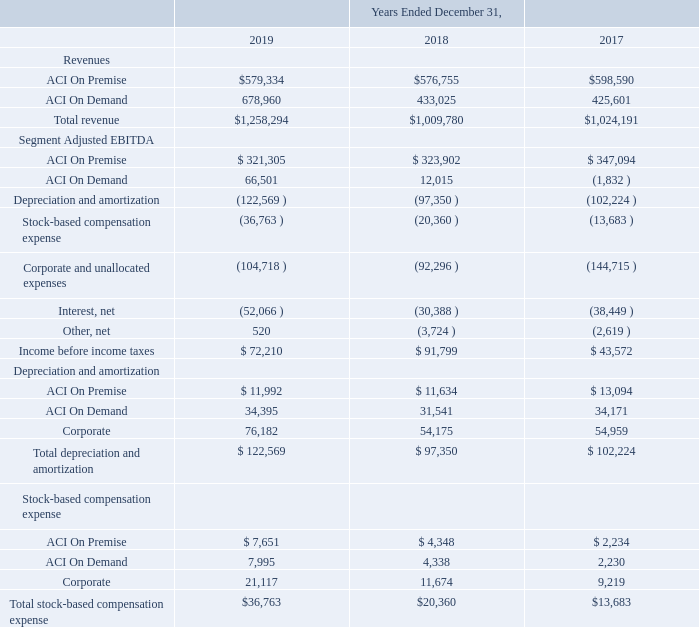10. Segment Information
The Company reports financial performance based on its segments, ACI On Premise and ACI On Demand, and analyzes Segment Adjusted EBITDA as a measure of segment profitability.
The Company’s interim Chief Executive Officer is also the chief operating decision maker ("CODM"). The CODM, together with other senior management personnel, focus their review on consolidated financial information and the allocation of resources based on operating results, including revenues and Segment Adjusted EBITDA, for each segment, separate from Corporate operations.
ACI On Premise serves customers who manage their software on site or through a third-party cloud service provider. These onpremise customers use the Company’s software to develop sophisticated solutions, which are often part of a larger system located and managed at the customer specified site. These customers require a level of control and flexibility that ACI On Premise solutions can offer, and they have the resources and expertise to take a lead role in managing these solutions.
ACI On Demand serves the needs of banks, merchants, and billers who use payments to facilitate their core business. These ondemand solutions are maintained and delivered through the cloud via our global data centers and are available in either a singletenant environment for SaaS offerings, or in a multi-tenant environment for PaaS offerings.
Revenue is attributed to the reportable segments based upon the product sold and mechanism for delivery to the customer. Expenses are attributed to the reportable segments in one of three methods, (1) direct costs of the segment, (2) labor costs that can be attributed based upon time tracking for individual products, or (3) costs that are allocated. Allocated costs are generally marketing and sales related activities as well as information technology and facilities related expense for which multiple segments benefit. The Company also allocates certain depreciation costs to the segments.
Segment Adjusted EBITDA is the measure reported to the CODM for purposes of making decisions on allocating resources and assessing the performance of the Company’s segments and, therefore, Segment Adjusted EBITDA is presented in conformity with ASC 280, Segment Reporting. Segment Adjusted EBITDA is defined as earnings (loss) from operations before interest, income tax expense (benefit), depreciation and amortization (“EBITDA”) adjusted to exclude stock-based compensation, and net other income (expense).
Corporate and unallocated expenses consist of the corporate overhead costs that are not allocated to reportable segments. These overhead costs relate to human resources, finance, legal, accounting, merger and acquisition activity, and other costs that are not considered when management evaluates segment performance. For the year ended December 31, 2017, corporate and unallocated expenses included $46.7 million of general and administrative expense for the legal judgment discussed in Note 15, Commitments and Contingencies.
The following is selected financial data for the Company’s reportable segments for the periods indicated (in thousands):
Assets are not allocated to segments, and the Company’s CODM does not evaluate operating segments using discrete asset information.
Which group of people does ACI on Premise serve? Customers who manage their software on site or through a third-party cloud service provider. Which group of people does ACI on Demand serve? The needs of banks, merchants, and billers who use payments to facilitate their core business. What was the ACI on Premise revenue in 2019?
Answer scale should be: thousand. $579,334. What was the change in ACI on demand revenue between 2018 and 2019?
Answer scale should be: thousand. 678,960-433,025
Answer: 245935. What was the change in total revenue between 2018 and 2017?
Answer scale should be: thousand. $1,009,780-$1,024,191
Answer: -14411. What was the percentage change in Total stock-based compensation expense between 2018 and 2019?
Answer scale should be: percent. ($36,763-$20,360)/$20,360
Answer: 80.56. 